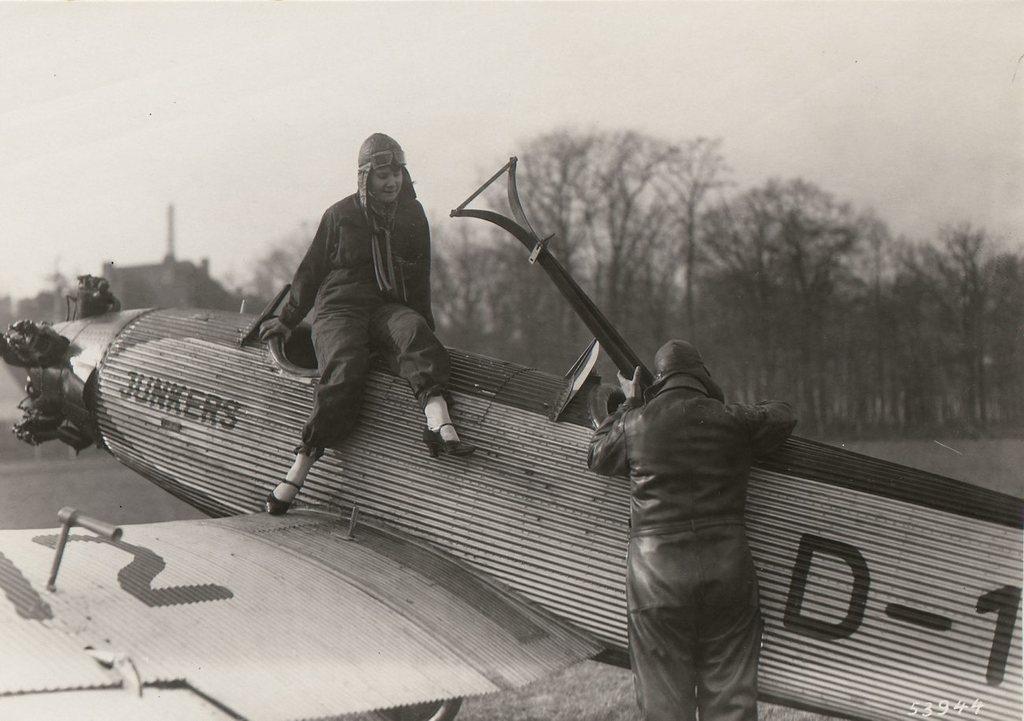How would you summarize this image in a sentence or two? In this image we can see a person holding a rod in his hand and standing on the ground. One women wearing helmet and goggles is sitting on the airplane placed on the ground. In the background we can see group of trees ,building and sky. 